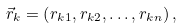<formula> <loc_0><loc_0><loc_500><loc_500>\vec { r } _ { k } = \left ( r _ { k 1 } , r _ { k 2 } , \dots , r _ { k n } \right ) ,</formula> 